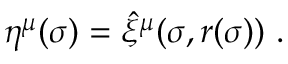Convert formula to latex. <formula><loc_0><loc_0><loc_500><loc_500>\eta ^ { \mu } ( \sigma ) = \hat { \xi } ^ { \mu } ( \sigma , r ( \sigma ) ) \ .</formula> 